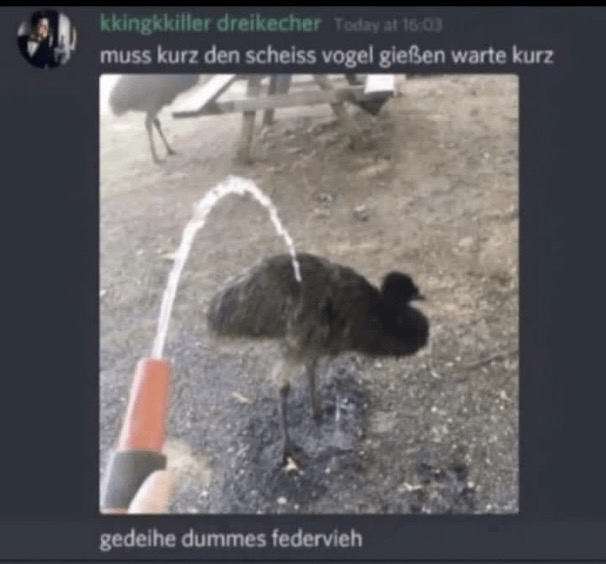What is in this image?
 The image appears to be a screenshot from a chat or social media platform. It shows a person using a hose to spray water on a large bird, which looks like an emu or an ostrich. The text above the image is in German and roughly translates to:

"I have to quickly water the damn bird, wait a moment"

And the text below the image translates to:

"Grow, you stupid feathered animal"

This seems to be a humorous attempt to mock the idea of watering a bird as if it were a plant. 